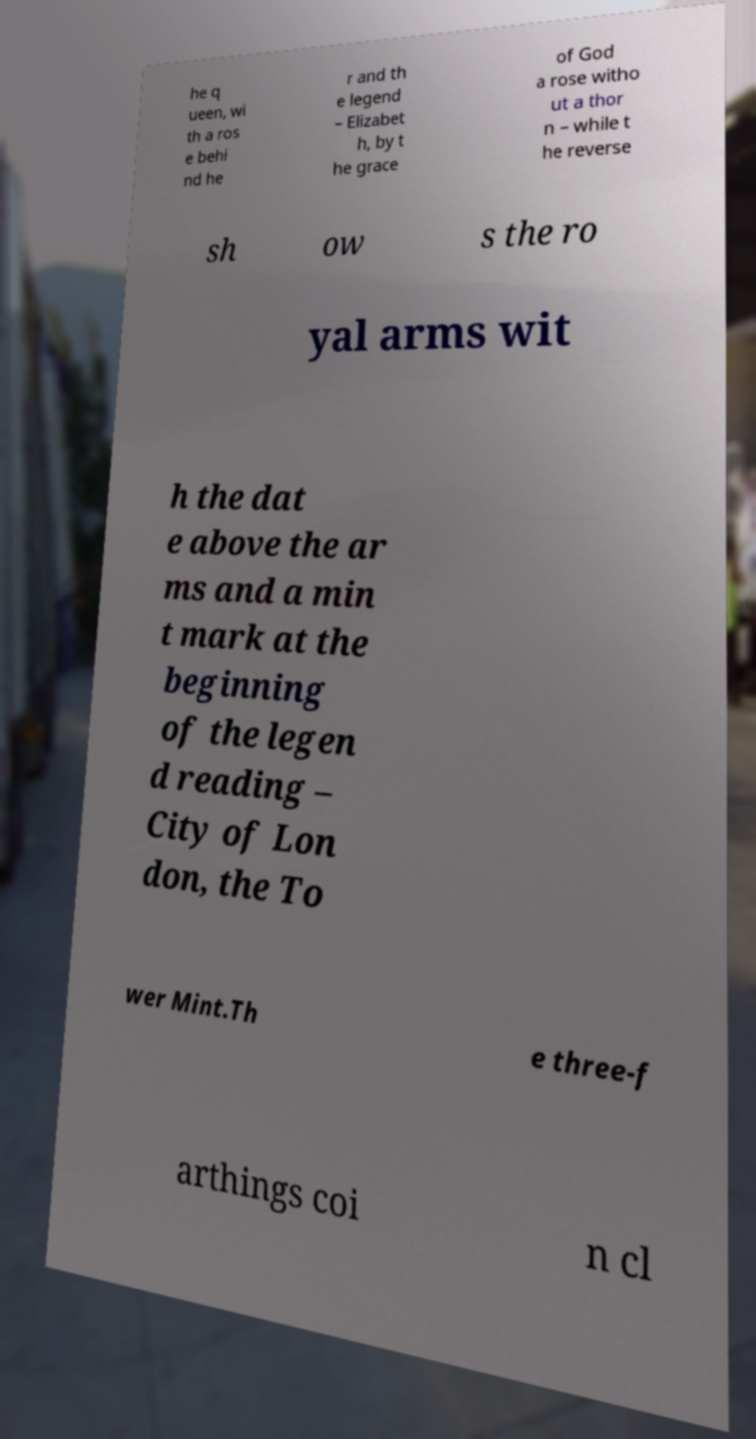Please identify and transcribe the text found in this image. he q ueen, wi th a ros e behi nd he r and th e legend – Elizabet h, by t he grace of God a rose witho ut a thor n – while t he reverse sh ow s the ro yal arms wit h the dat e above the ar ms and a min t mark at the beginning of the legen d reading – City of Lon don, the To wer Mint.Th e three-f arthings coi n cl 